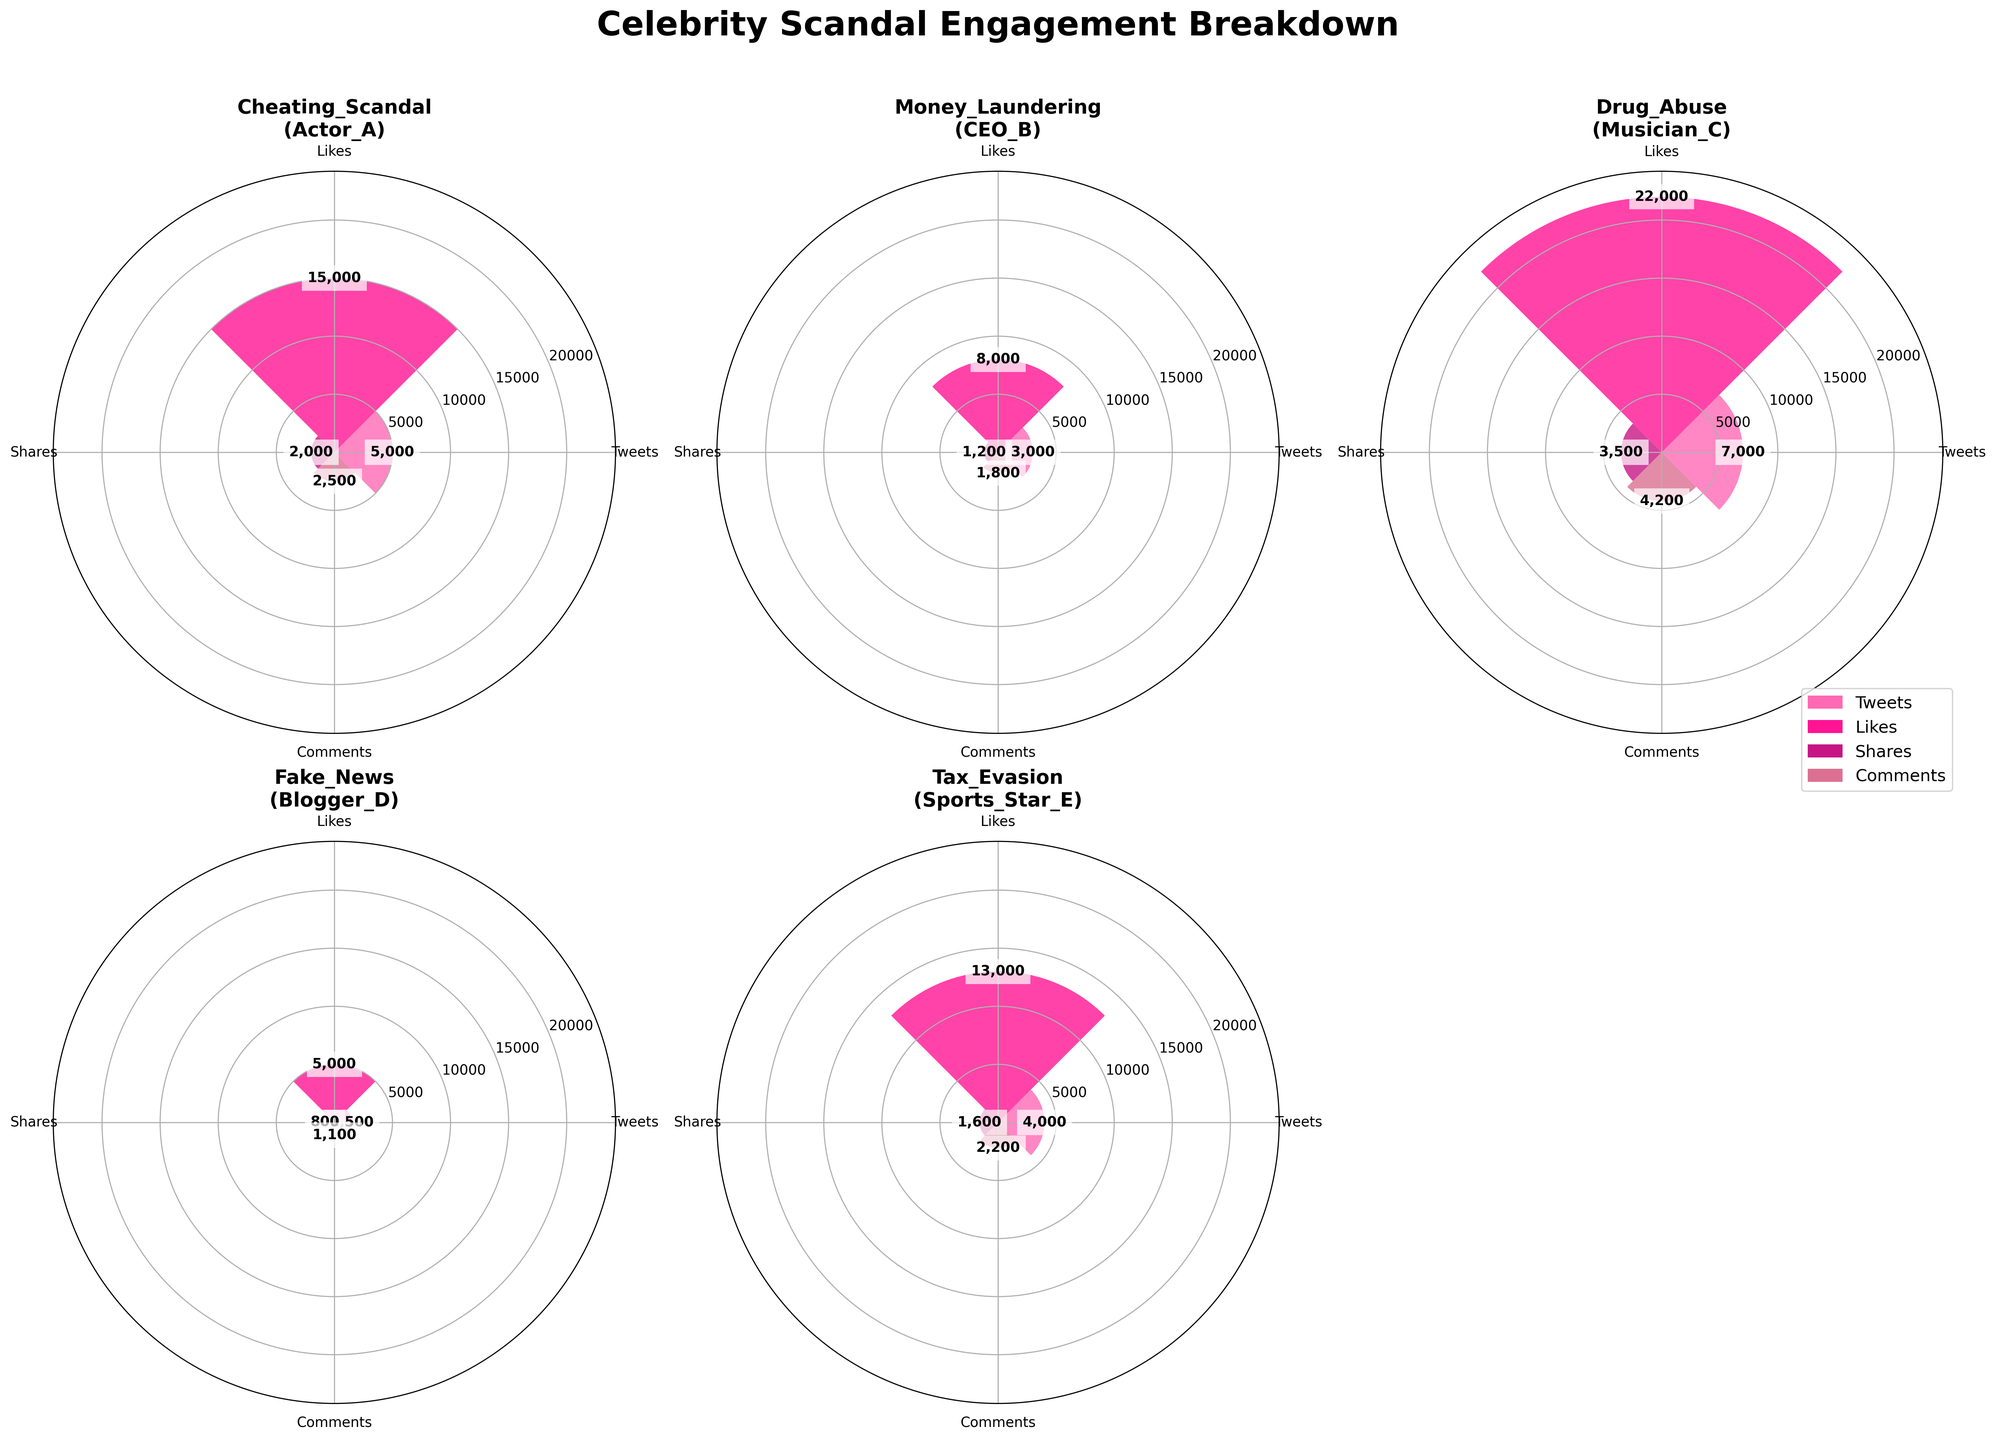What is the title of the plot? The title is written at the top center of the plot. It reads "Celebrity Scandal Engagement Breakdown."
Answer: Celebrity Scandal Engagement Breakdown Which scandal type has the highest total engagement? By looking at the height (radii) of the bars for each scandal type, add the values of all engagement types (tweets, likes, shares, comments) for each scandal. The Drug Abuse scandal (Musician_C) shows the highest total engagement when summed up (7000 + 22000 + 3500 + 4200 = 36700).
Answer: Drug Abuse (Musician_C) How does the number of tweets for the cheating scandal compare to the fake news scandal? Look at the bar heights in the figure corresponding to tweets for each scandal type. The Cheating Scandal has 5000 tweets, whereas the Fake News scandal has 1500 tweets. Comparing these two values, the Cheating Scandal has more tweets.
Answer: The Cheating Scandal has more tweets Which engagement type has the lowest amount for the Money Laundering scandal? By observing the shortest bar for the Money Laundering scandal (CEO_B), the shares bar has the lowest amount with a value of 1200.
Answer: Shares What is the sum of likes and comments for the Tax Evasion scandal? Find the values for likes and comments for the Tax Evasion scandal (Sports_Star_E) and add them together. Likes: 13000, Comments: 2200. Therefore, the sum is 13000 + 2200 = 15200.
Answer: 15200 Which engagement type varies the most across all scandals? Compare the extent of variation in bar heights across all subplots. The 'Likes' engagement type shows the highest variability, with values ranging from 5000 (Fake News) to 22000 (Drug Abuse).
Answer: Likes Which scandal type has the least shares, and how many are there? Examine the shares bars across all scandals. The Fake News scandal (Blogger_D) has the least shares with a value of 800.
Answer: Fake News (800) What is the average number of comments across all scandals? Sum the number of comments for all scandals and then divide by the number of scandals. Comments for all scandals are: 2500 + 1800 + 4200 + 1100 + 2200 = 11800. There are 5 scandals, so the average is 11800 / 5 = 2360.
Answer: 2360 Which scandal has the highest engagement in terms of tweets and what is that value? Identify the tallest tweet bar across all scandal types. The Drug Abuse scandal (Musician_C) has the highest number of tweets with a value of 7000.
Answer: Drug Abuse (7000) 